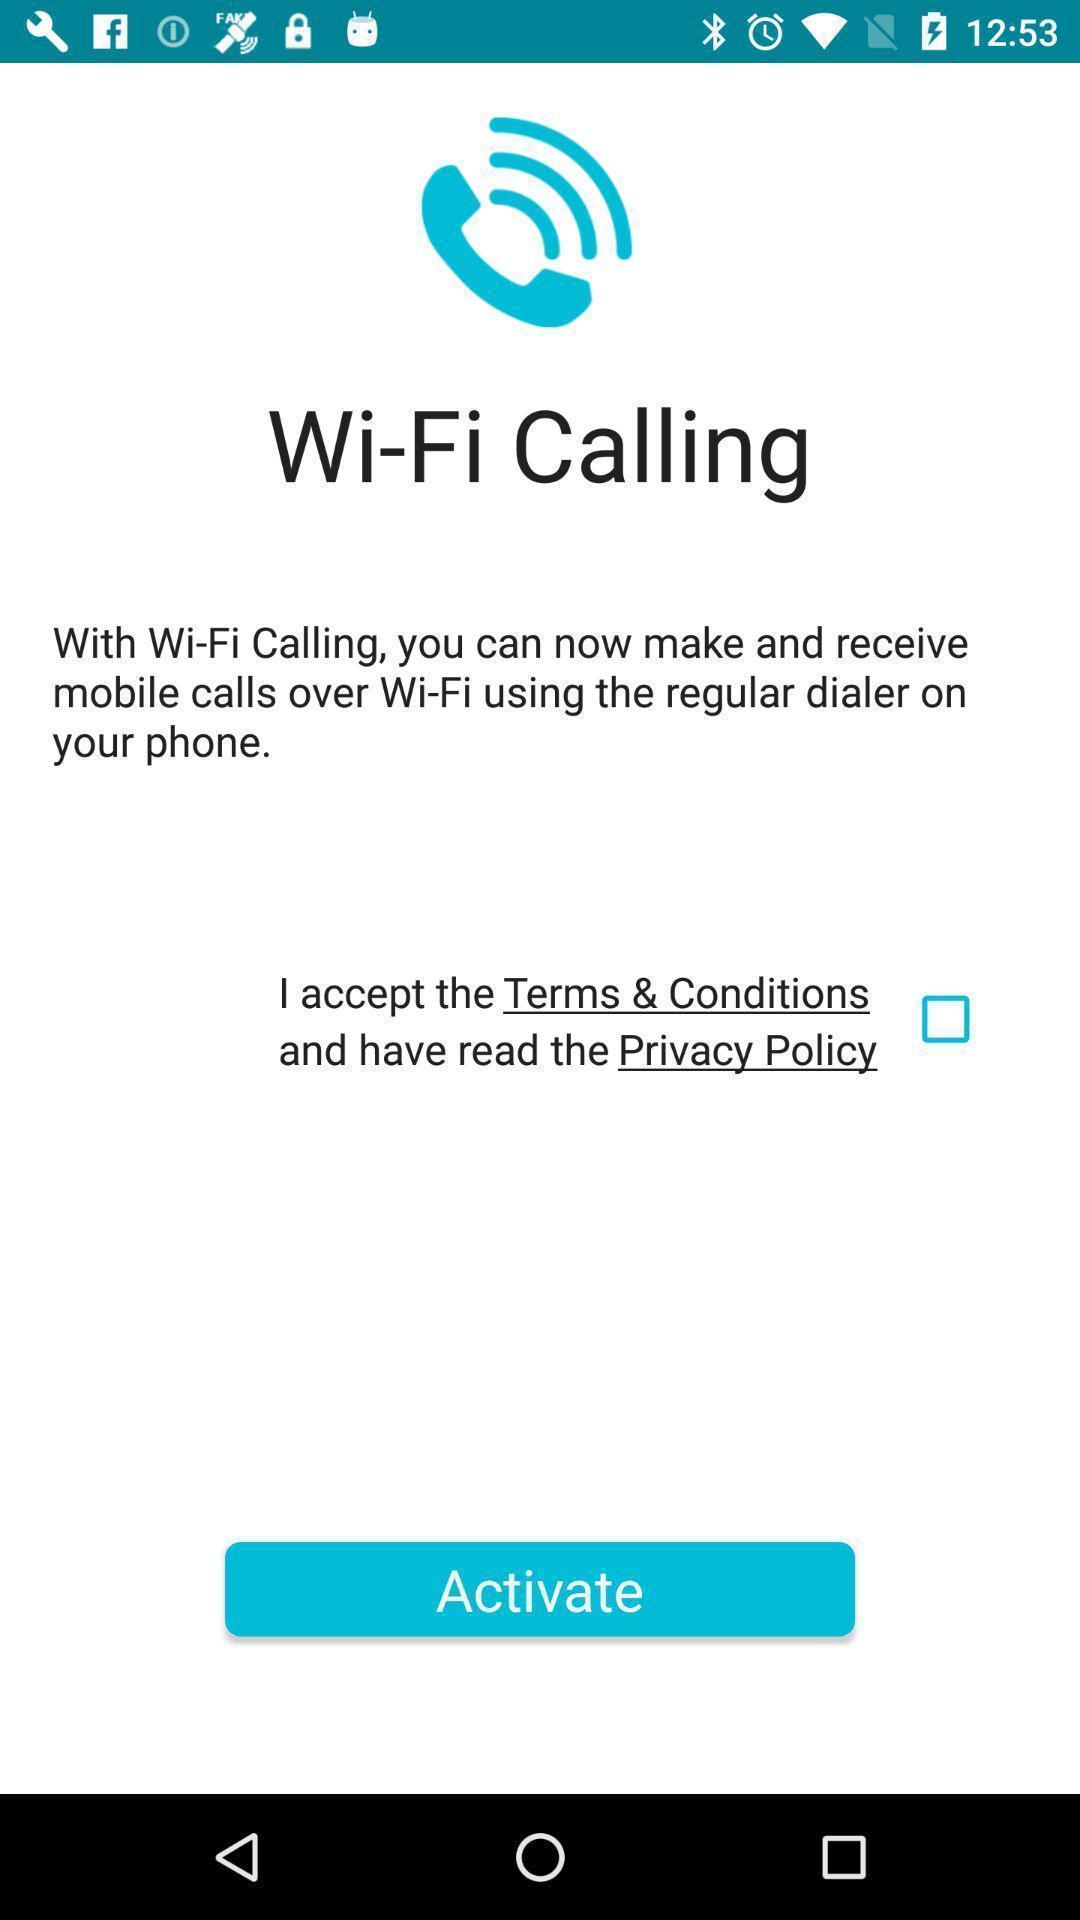Give me a narrative description of this picture. Wi-fi calling to activate in the application. 